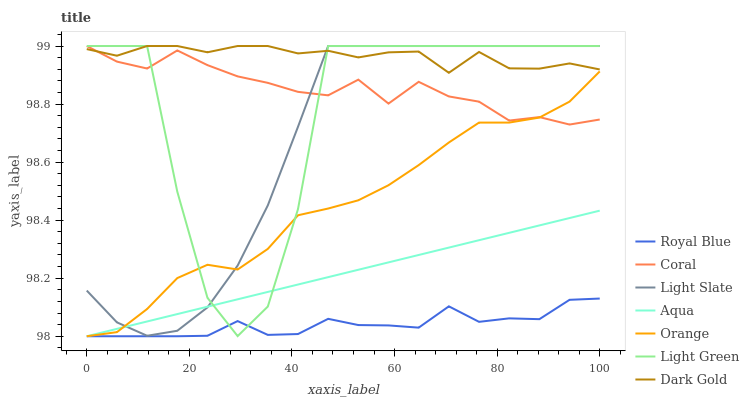Does Royal Blue have the minimum area under the curve?
Answer yes or no. Yes. Does Dark Gold have the maximum area under the curve?
Answer yes or no. Yes. Does Light Slate have the minimum area under the curve?
Answer yes or no. No. Does Light Slate have the maximum area under the curve?
Answer yes or no. No. Is Aqua the smoothest?
Answer yes or no. Yes. Is Light Green the roughest?
Answer yes or no. Yes. Is Light Slate the smoothest?
Answer yes or no. No. Is Light Slate the roughest?
Answer yes or no. No. Does Aqua have the lowest value?
Answer yes or no. Yes. Does Light Slate have the lowest value?
Answer yes or no. No. Does Light Green have the highest value?
Answer yes or no. Yes. Does Aqua have the highest value?
Answer yes or no. No. Is Aqua less than Dark Gold?
Answer yes or no. Yes. Is Light Slate greater than Royal Blue?
Answer yes or no. Yes. Does Coral intersect Dark Gold?
Answer yes or no. Yes. Is Coral less than Dark Gold?
Answer yes or no. No. Is Coral greater than Dark Gold?
Answer yes or no. No. Does Aqua intersect Dark Gold?
Answer yes or no. No. 